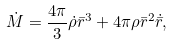Convert formula to latex. <formula><loc_0><loc_0><loc_500><loc_500>\dot { M } = \frac { 4 \pi } { 3 } \dot { \rho } \bar { r } ^ { 3 } + 4 \pi \rho \bar { r } ^ { 2 } \dot { \bar { r } } ,</formula> 